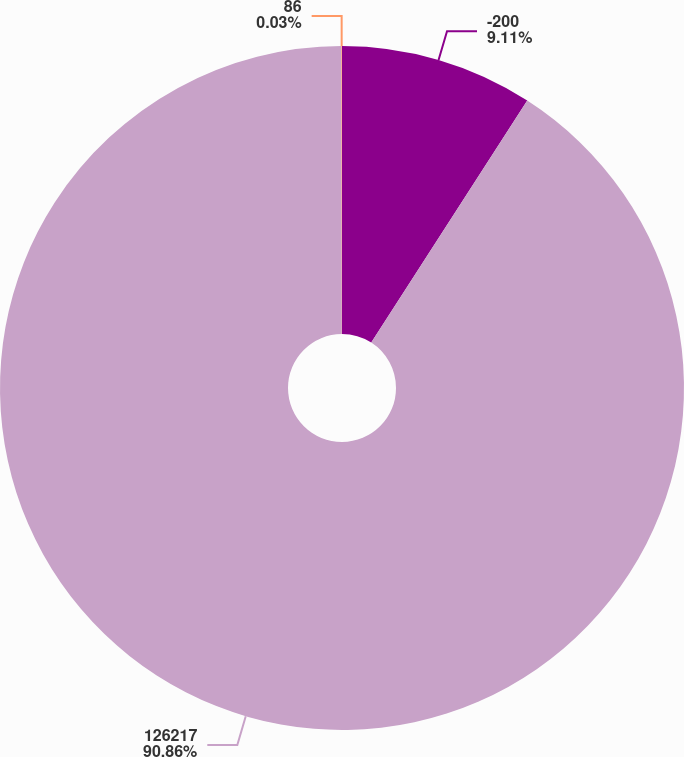Convert chart. <chart><loc_0><loc_0><loc_500><loc_500><pie_chart><fcel>-200<fcel>126217<fcel>86<nl><fcel>9.11%<fcel>90.85%<fcel>0.03%<nl></chart> 